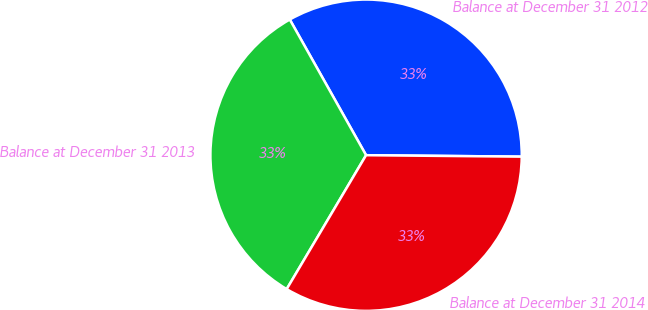<chart> <loc_0><loc_0><loc_500><loc_500><pie_chart><fcel>Balance at December 31 2012<fcel>Balance at December 31 2013<fcel>Balance at December 31 2014<nl><fcel>33.3%<fcel>33.33%<fcel>33.37%<nl></chart> 